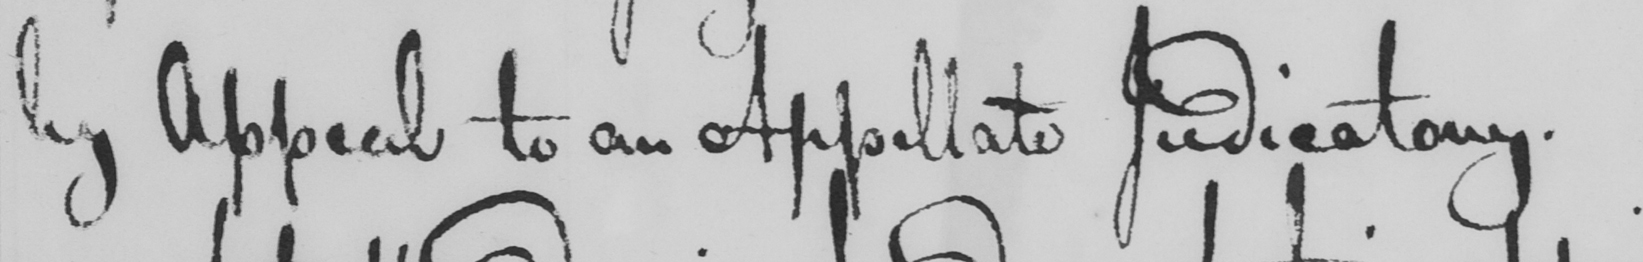What is written in this line of handwriting? by Appeal to an Appellate Judicatory . 